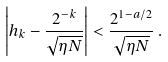<formula> <loc_0><loc_0><loc_500><loc_500>\left | h _ { k } - \frac { 2 ^ { - k } } { \sqrt { \eta N } } \right | < \frac { 2 ^ { 1 - a / 2 } } { \sqrt { \eta N } } \, .</formula> 